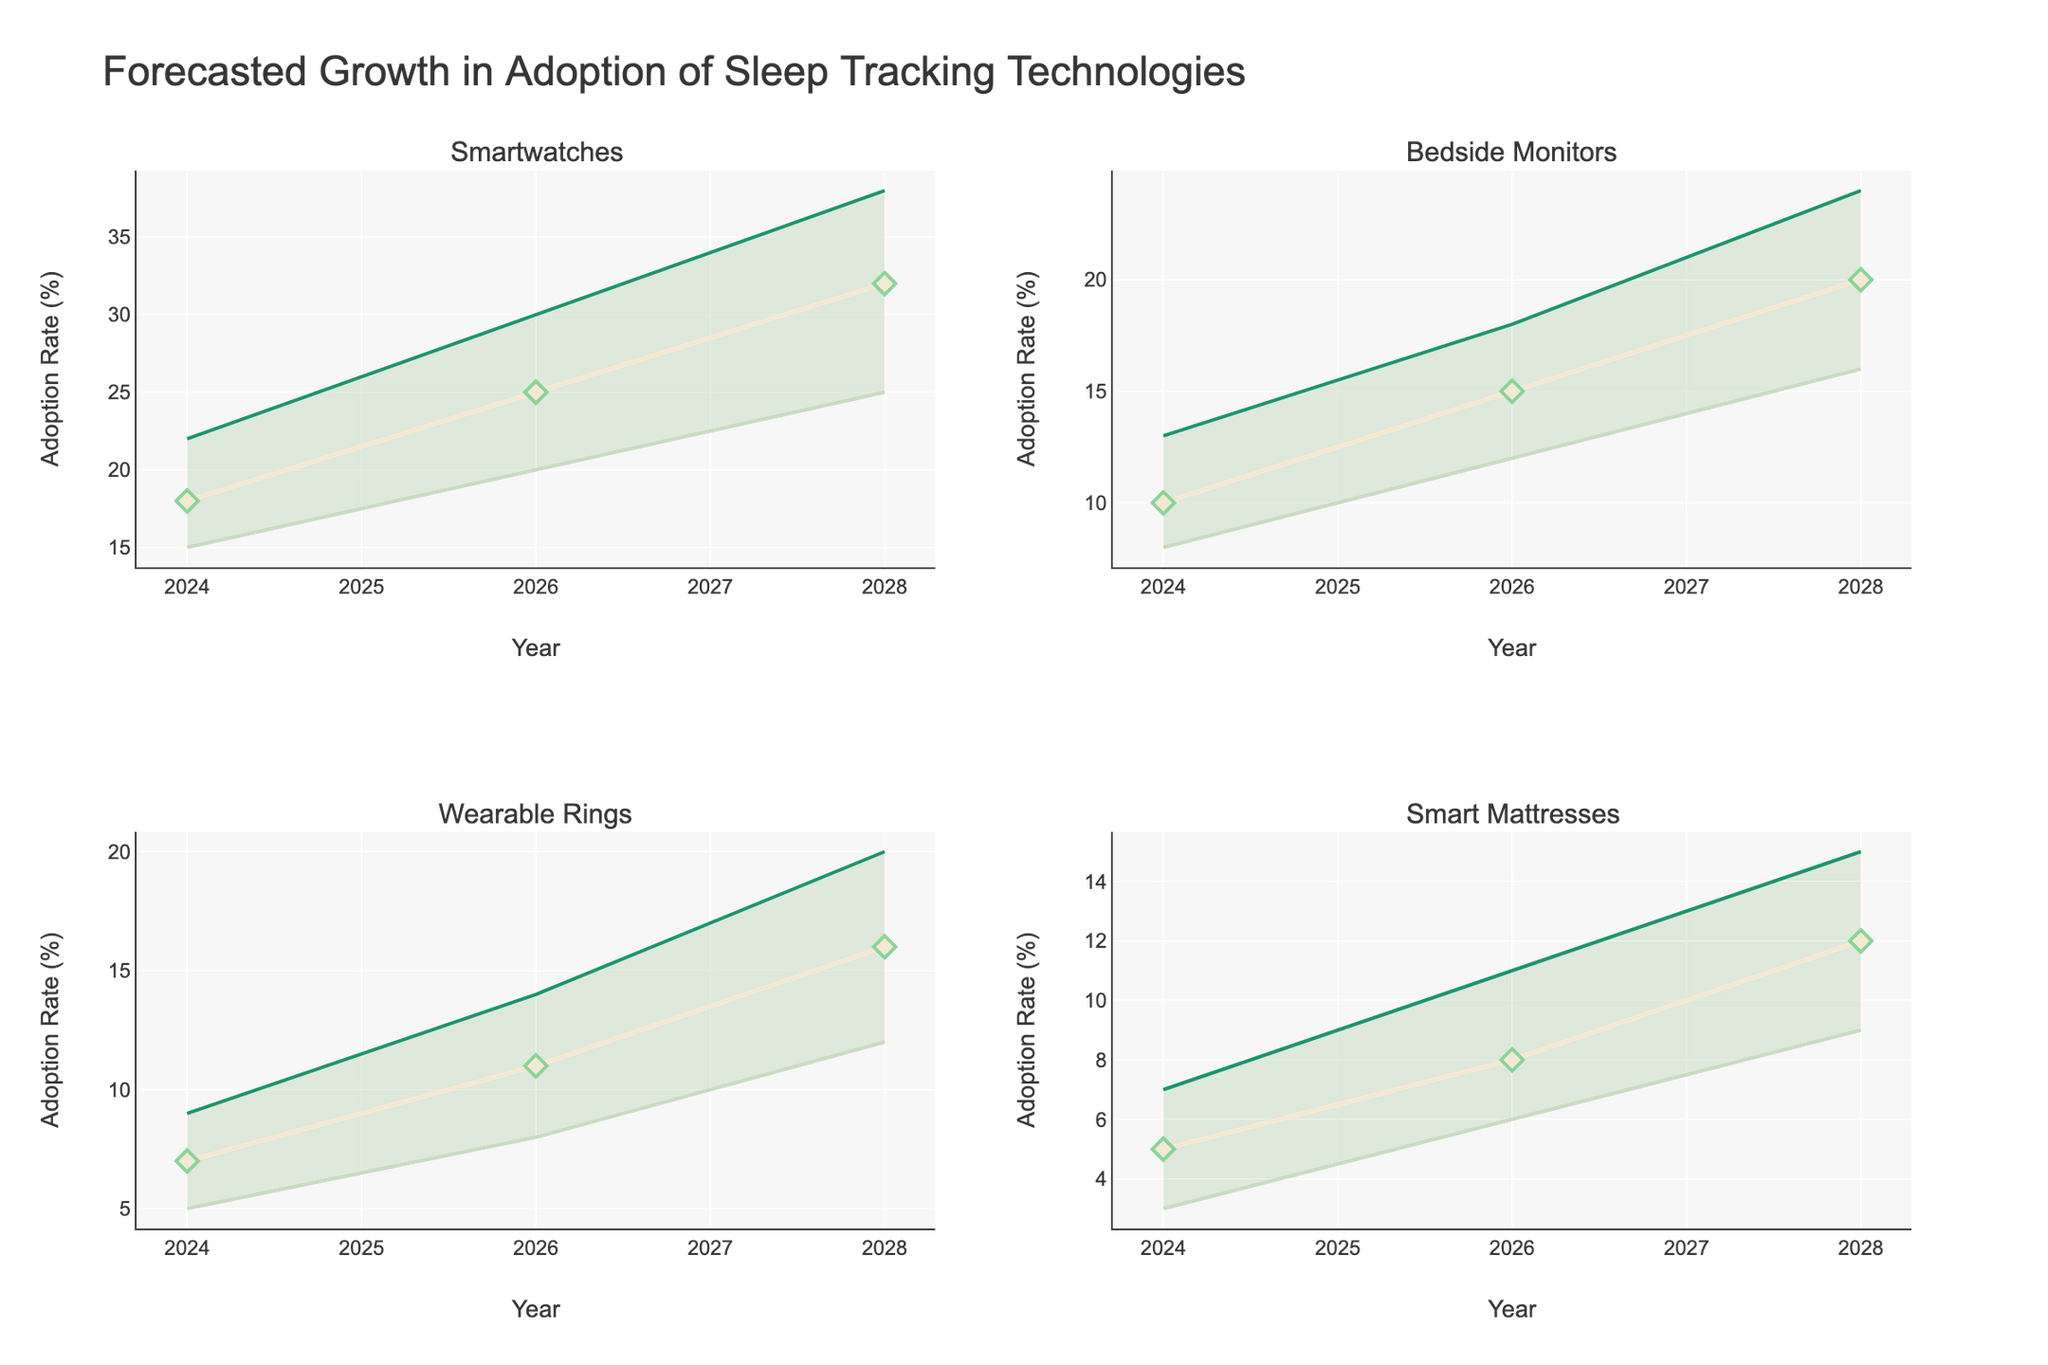what is the highest adoption rate for Smartwatches in 2028? Looking at the subplot for Smartwatches, the high estimate line for 2028 peaks at 38%.
Answer: 38% In which year is the lowest estimated adoption rate for Smart Mattresses? Observing the Smart Mattresses subplot, the lowest estimate value is at 2024 with an adoption rate of 3%.
Answer: 2024 Which device type shows the greatest difference between high and low estimates in 2026? By examining all the subplots for 2026, the difference between high and low estimates can be calculated for each device type:
- Smartwatches: 30 - 20 = 10
- Bedside Monitors: 18 - 12 = 6
- Wearable Rings: 14 - 8 = 6
- Smart Mattresses: 11 - 6 = 5
Smartwatches have the greatest difference at 10.
Answer: Smartwatches How do the medium estimates for Wearable Rings change from 2024 to 2028? The subplot for Wearable Rings shows a medium estimate of 7 in 2024, 11 in 2026, and 16 in 2028. The change is calculated as follows:
- From 2024 to 2026: 11 - 7 = 4
- From 2026 to 2028: 16 - 11 = 5
- From 2024 to 2028: 16 - 7 = 9
There is an overall increase of 9 percentage points from 2024 to 2028.
Answer: Increase by 9 percentage points Which device type has the most consistent growth based on the medium estimate line? Consistent growth can be evaluated by the smoothness and linearity of the medium estimate lines for each device:
- Smartwatches: Medium estimate increases steadily.
- Bedside Monitors: Medium estimate increases steadily.
- Wearable Rings: Medium estimate increases steadily.
- Smart Mattresses: Medium estimate increases steadily, though at a slower rate.
All devices show consistent growth, but since Bedside Monitors and Wearable Rings have a more noticeable rate of growth in the medium term, they may be considered more consistent.
Answer: Bedside Monitors and Wearable Rings 